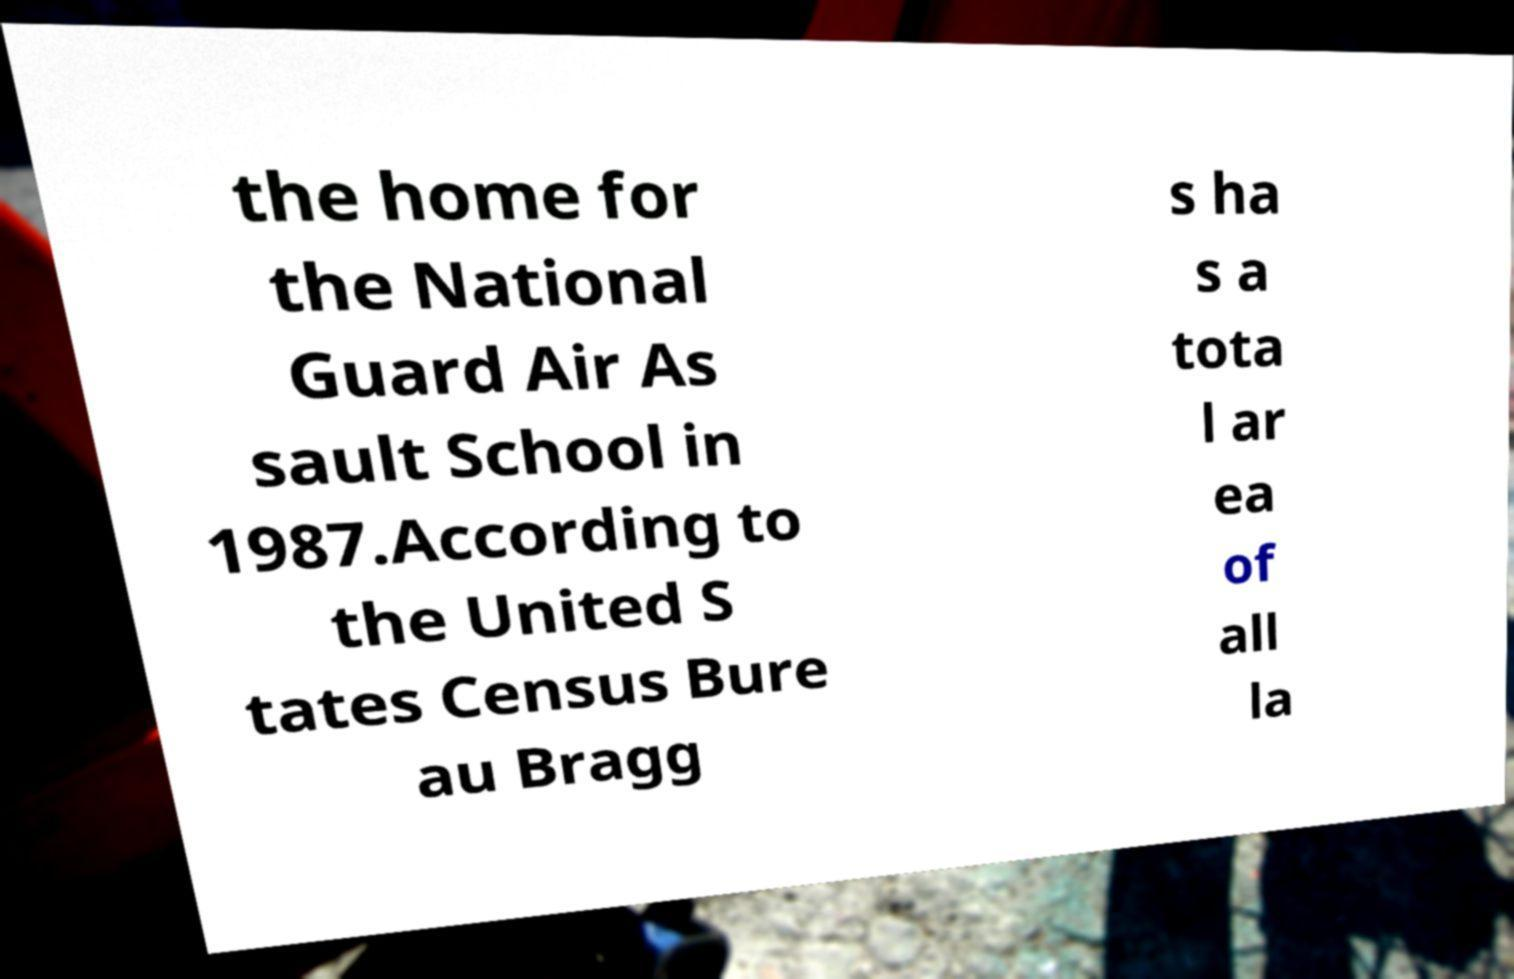Please read and relay the text visible in this image. What does it say? the home for the National Guard Air As sault School in 1987.According to the United S tates Census Bure au Bragg s ha s a tota l ar ea of all la 